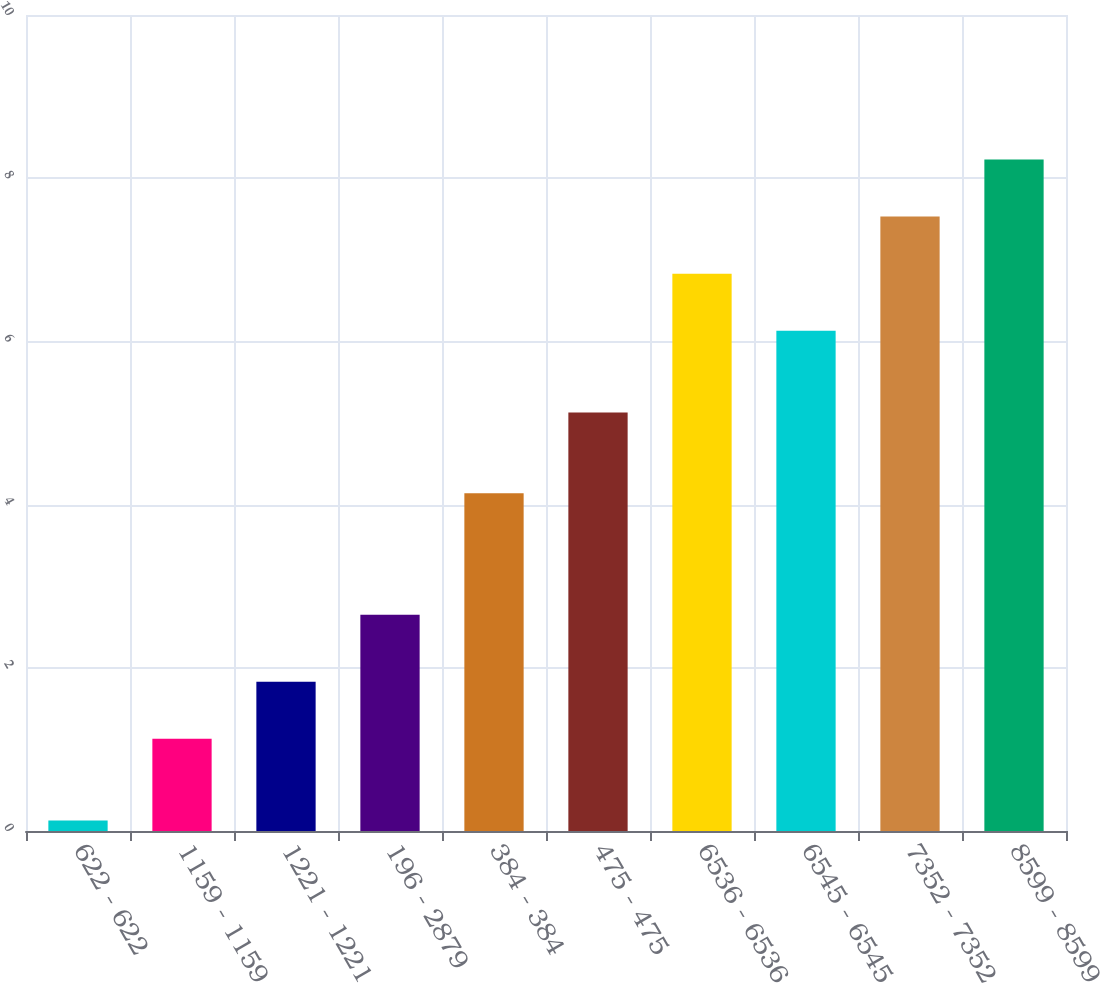Convert chart to OTSL. <chart><loc_0><loc_0><loc_500><loc_500><bar_chart><fcel>622 - 622<fcel>1159 - 1159<fcel>1221 - 1221<fcel>196 - 2879<fcel>384 - 384<fcel>475 - 475<fcel>6536 - 6536<fcel>6545 - 6545<fcel>7352 - 7352<fcel>8599 - 8599<nl><fcel>0.13<fcel>1.13<fcel>1.83<fcel>2.65<fcel>4.14<fcel>5.13<fcel>6.83<fcel>6.13<fcel>7.53<fcel>8.23<nl></chart> 